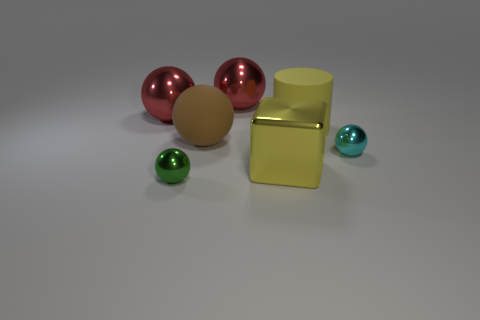What do the different textures in the image convey? The contrasting textures in the image range from the smoothness of the metallic spheres to the perceived softness of the beige rubber ball. This variety in tactile quality suggests diversity and the coexistence of different elements in a harmonious state. How does the composition of the objects in the image affect its visual balance? The objects are arranged in a way that provides visual balance through symmetry and spacing. The eye is drawn around the image, encouraged by the placement of the objects, which creates a sense of equilibrium and aesthetic appeal. 